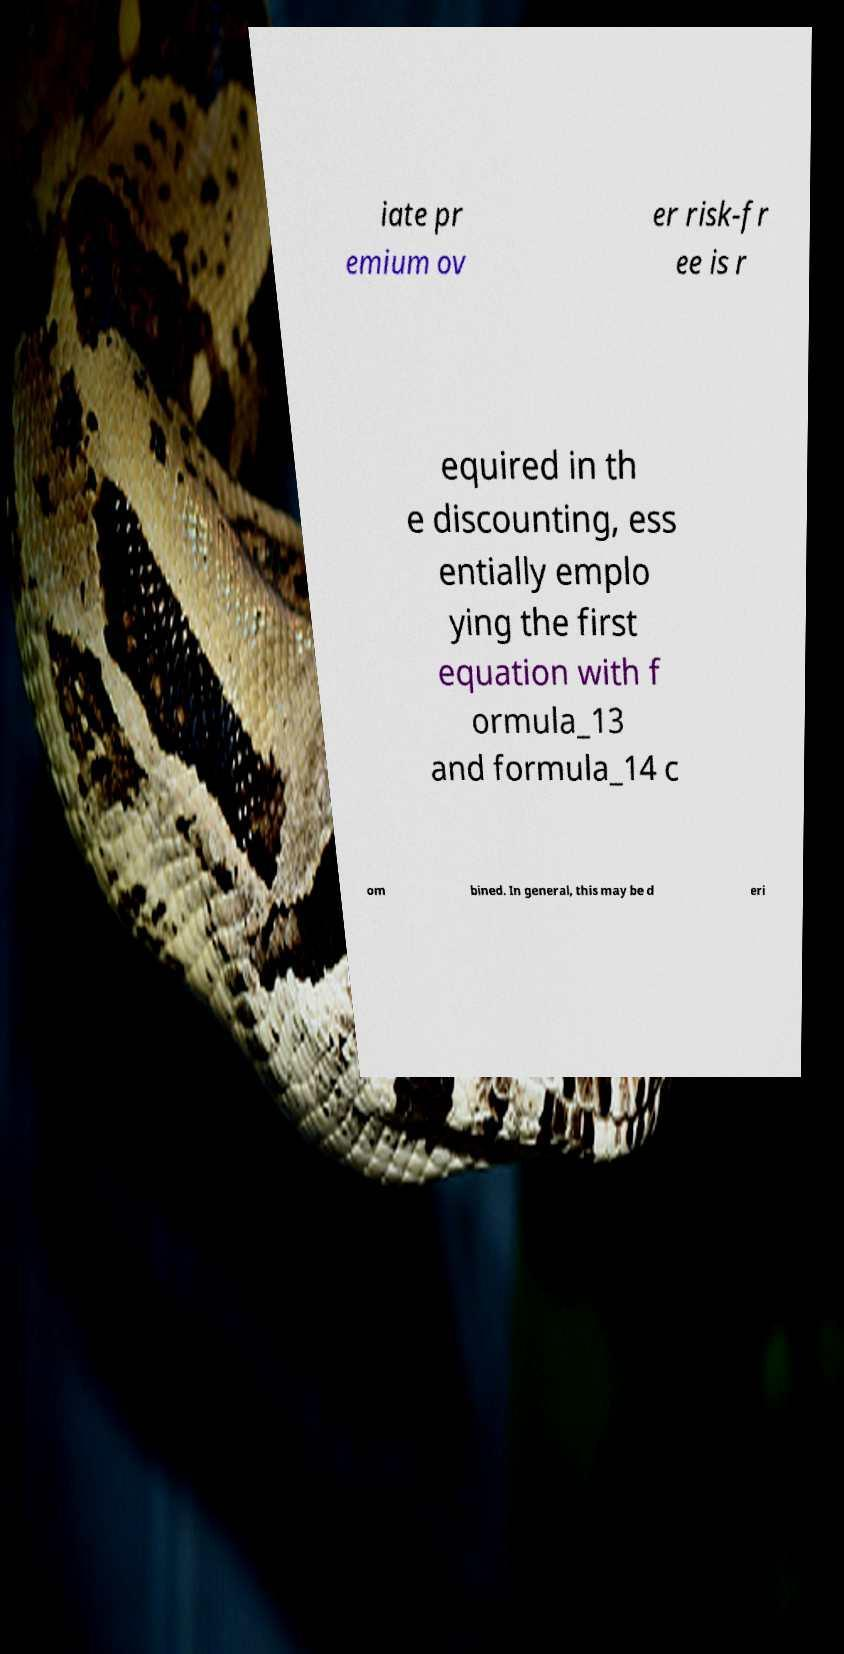Can you read and provide the text displayed in the image?This photo seems to have some interesting text. Can you extract and type it out for me? iate pr emium ov er risk-fr ee is r equired in th e discounting, ess entially emplo ying the first equation with f ormula_13 and formula_14 c om bined. In general, this may be d eri 